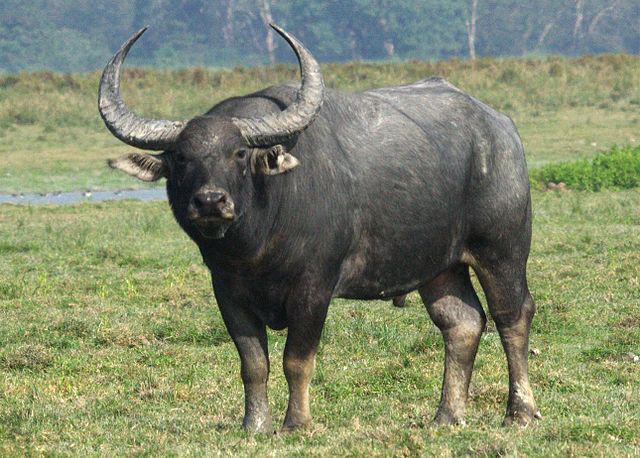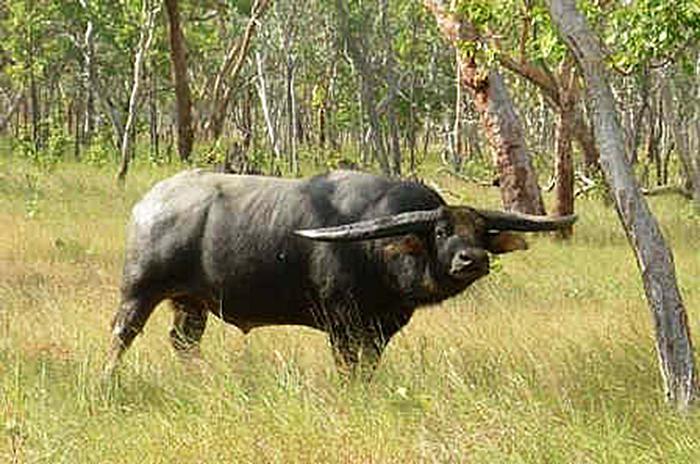The first image is the image on the left, the second image is the image on the right. Analyze the images presented: Is the assertion "There are no less than two Water Buffalo in one of the images." valid? Answer yes or no. No. The first image is the image on the left, the second image is the image on the right. Examine the images to the left and right. Is the description "In one image there is a lone water buffalo standing in water." accurate? Answer yes or no. No. 